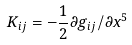<formula> <loc_0><loc_0><loc_500><loc_500>K _ { i j } = - \frac { 1 } { 2 } \partial g _ { i j } / \partial x ^ { 5 }</formula> 